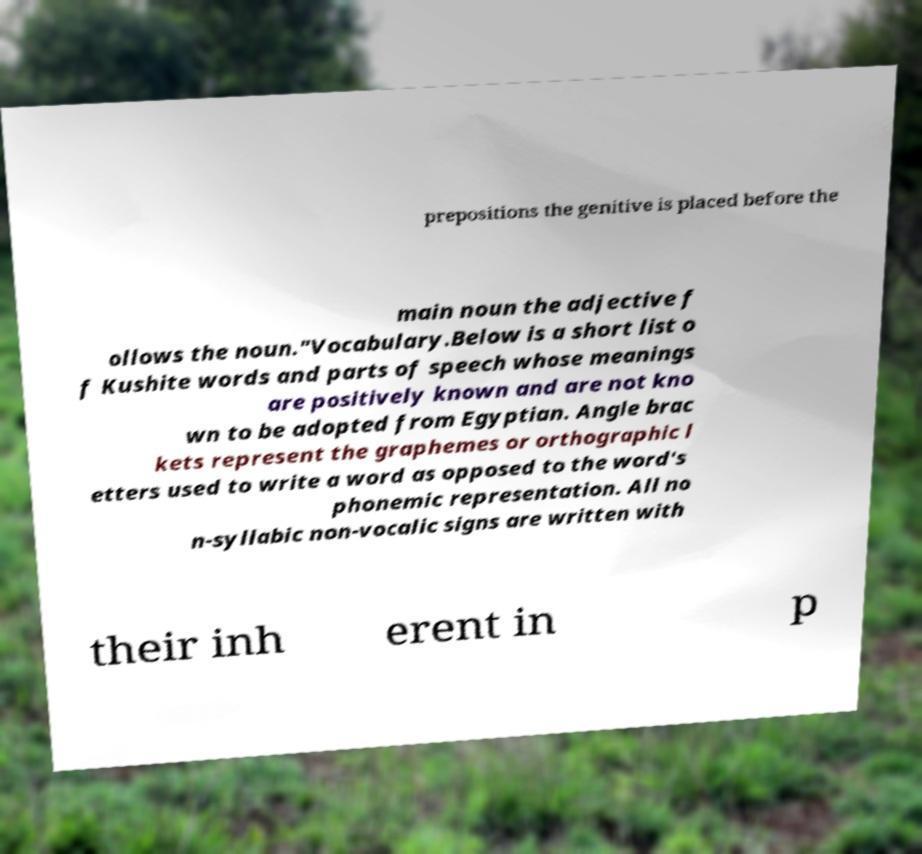Please read and relay the text visible in this image. What does it say? prepositions the genitive is placed before the main noun the adjective f ollows the noun."Vocabulary.Below is a short list o f Kushite words and parts of speech whose meanings are positively known and are not kno wn to be adopted from Egyptian. Angle brac kets represent the graphemes or orthographic l etters used to write a word as opposed to the word's phonemic representation. All no n-syllabic non-vocalic signs are written with their inh erent in p 